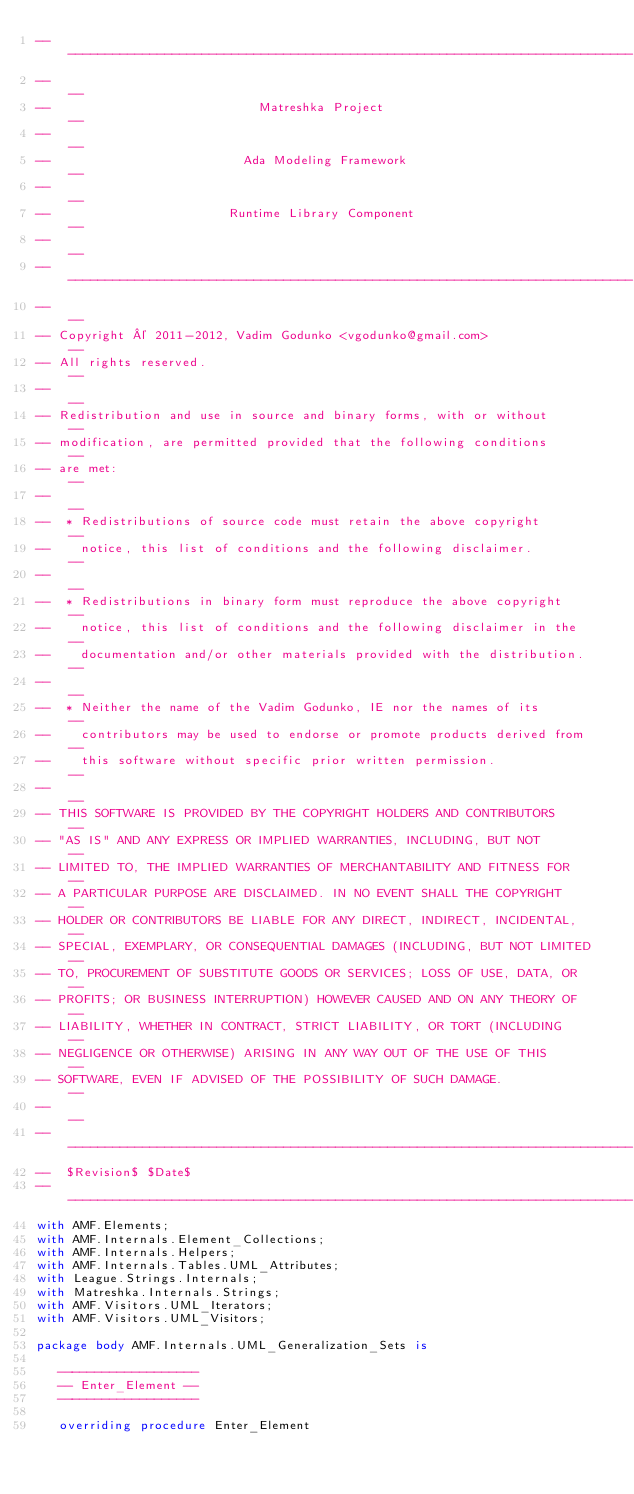Convert code to text. <code><loc_0><loc_0><loc_500><loc_500><_Ada_>------------------------------------------------------------------------------
--                                                                          --
--                            Matreshka Project                             --
--                                                                          --
--                          Ada Modeling Framework                          --
--                                                                          --
--                        Runtime Library Component                         --
--                                                                          --
------------------------------------------------------------------------------
--                                                                          --
-- Copyright © 2011-2012, Vadim Godunko <vgodunko@gmail.com>                --
-- All rights reserved.                                                     --
--                                                                          --
-- Redistribution and use in source and binary forms, with or without       --
-- modification, are permitted provided that the following conditions       --
-- are met:                                                                 --
--                                                                          --
--  * Redistributions of source code must retain the above copyright        --
--    notice, this list of conditions and the following disclaimer.         --
--                                                                          --
--  * Redistributions in binary form must reproduce the above copyright     --
--    notice, this list of conditions and the following disclaimer in the   --
--    documentation and/or other materials provided with the distribution.  --
--                                                                          --
--  * Neither the name of the Vadim Godunko, IE nor the names of its        --
--    contributors may be used to endorse or promote products derived from  --
--    this software without specific prior written permission.              --
--                                                                          --
-- THIS SOFTWARE IS PROVIDED BY THE COPYRIGHT HOLDERS AND CONTRIBUTORS      --
-- "AS IS" AND ANY EXPRESS OR IMPLIED WARRANTIES, INCLUDING, BUT NOT        --
-- LIMITED TO, THE IMPLIED WARRANTIES OF MERCHANTABILITY AND FITNESS FOR    --
-- A PARTICULAR PURPOSE ARE DISCLAIMED. IN NO EVENT SHALL THE COPYRIGHT     --
-- HOLDER OR CONTRIBUTORS BE LIABLE FOR ANY DIRECT, INDIRECT, INCIDENTAL,   --
-- SPECIAL, EXEMPLARY, OR CONSEQUENTIAL DAMAGES (INCLUDING, BUT NOT LIMITED --
-- TO, PROCUREMENT OF SUBSTITUTE GOODS OR SERVICES; LOSS OF USE, DATA, OR   --
-- PROFITS; OR BUSINESS INTERRUPTION) HOWEVER CAUSED AND ON ANY THEORY OF   --
-- LIABILITY, WHETHER IN CONTRACT, STRICT LIABILITY, OR TORT (INCLUDING     --
-- NEGLIGENCE OR OTHERWISE) ARISING IN ANY WAY OUT OF THE USE OF THIS       --
-- SOFTWARE, EVEN IF ADVISED OF THE POSSIBILITY OF SUCH DAMAGE.             --
--                                                                          --
------------------------------------------------------------------------------
--  $Revision$ $Date$
------------------------------------------------------------------------------
with AMF.Elements;
with AMF.Internals.Element_Collections;
with AMF.Internals.Helpers;
with AMF.Internals.Tables.UML_Attributes;
with League.Strings.Internals;
with Matreshka.Internals.Strings;
with AMF.Visitors.UML_Iterators;
with AMF.Visitors.UML_Visitors;

package body AMF.Internals.UML_Generalization_Sets is

   -------------------
   -- Enter_Element --
   -------------------

   overriding procedure Enter_Element</code> 